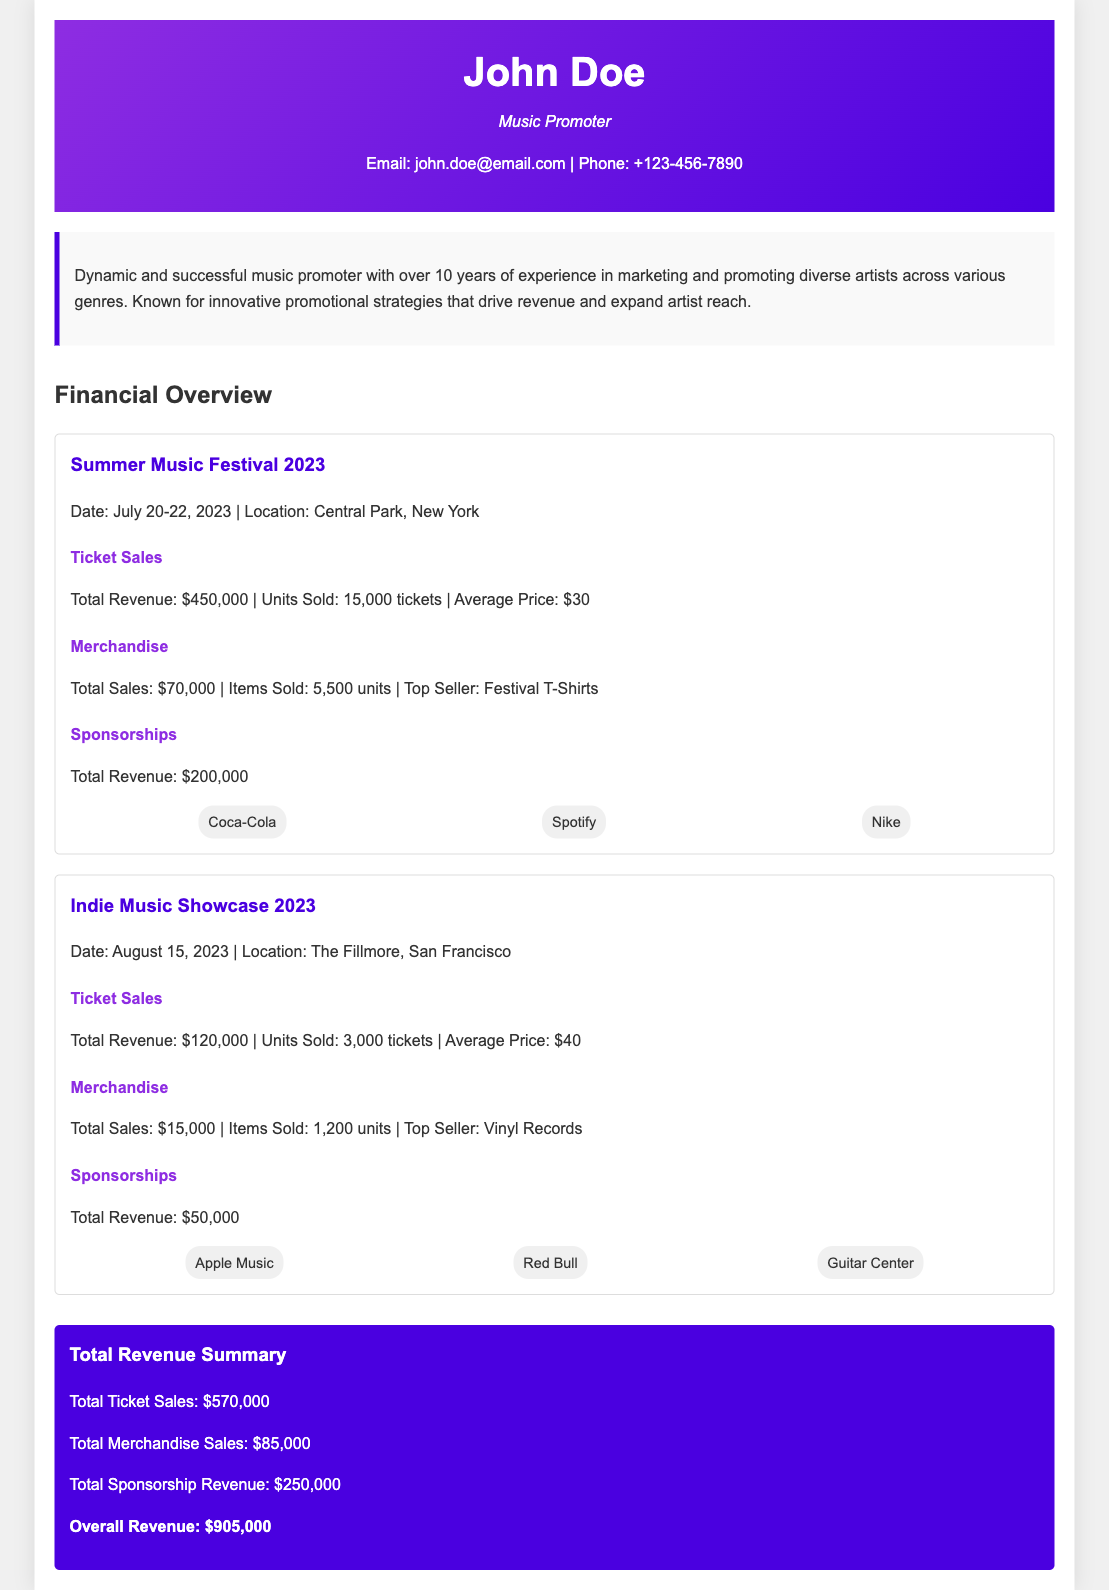what is the total revenue from ticket sales for the Summer Music Festival 2023? The total revenue from ticket sales for the Summer Music Festival 2023 is explicitly mentioned in the document.
Answer: $450,000 who are the sponsors for the Indie Music Showcase 2023? The document lists the sponsors for the Indie Music Showcase 2023, which includes three specific companies.
Answer: Apple Music, Red Bull, Guitar Center how many tickets were sold for the Summer Music Festival 2023? The document provides specific details about ticket sales for the Summer Music Festival 2023, including the number of units sold.
Answer: 15,000 tickets what is the average price of a ticket for the Indie Music Showcase 2023? The document mentions the total revenue from ticket sales and the number of tickets sold, allowing for calculation of the average price, which is explicitly stated.
Answer: $40 what was the top-selling merchandise item for the Summer Music Festival 2023? The document specifies the top-selling merchandise item which is highlighted clearly.
Answer: Festival T-Shirts what is the total merchandise sales across both events? The total merchandise sales are provided for each event, allowing for the calculation of the overall sales total, which is explicitly mentioned.
Answer: $85,000 what was the total revenue from sponsorships for both events? The document clearly states the total revenue from sponsorships for each event, enabling summation to find the overall total.
Answer: $250,000 when did the Indie Music Showcase 2023 take place? The document provides specific information about the date of the Indie Music Showcase 2023.
Answer: August 15, 2023 what is the overall total revenue from all sources for the events? The overall total revenue encompasses all forms of revenue from the events and is explicitly stated in the document.
Answer: $905,000 